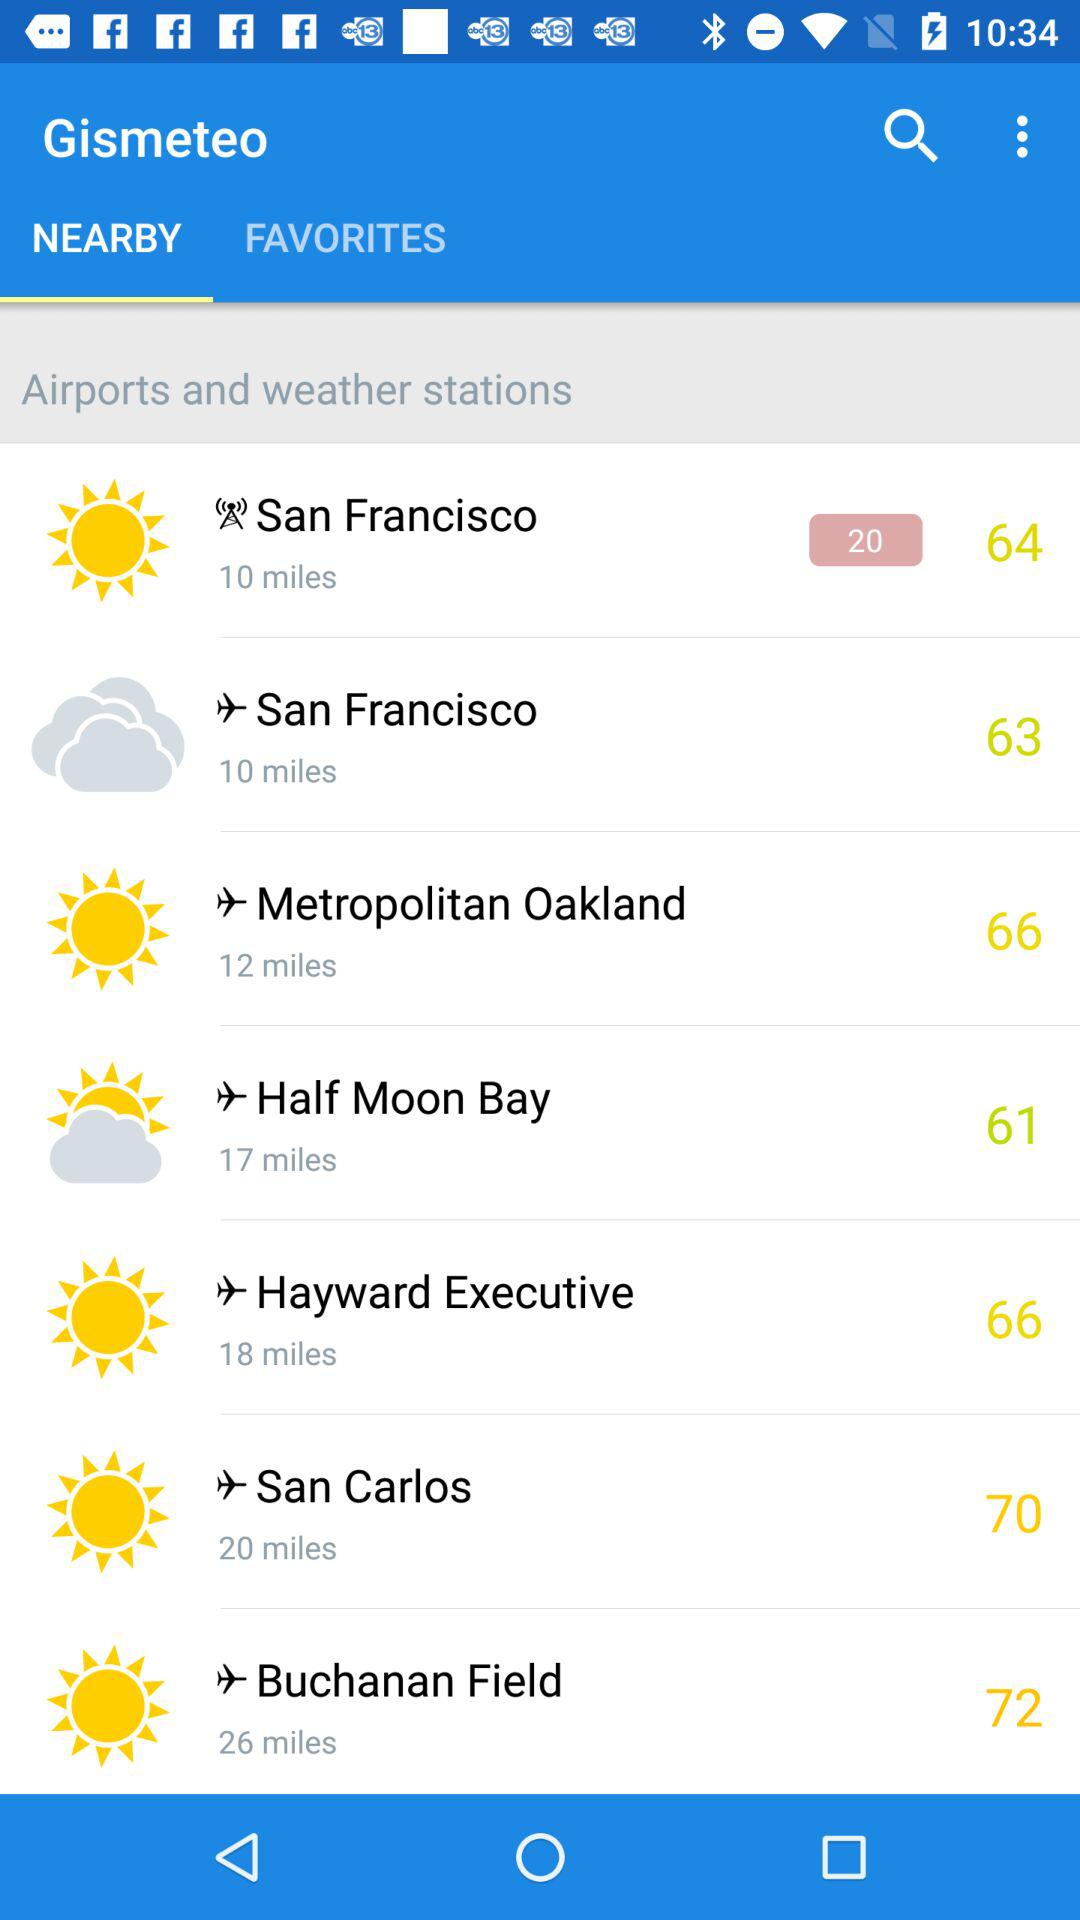Which tab has been selected? The tab that has been selected is "NEARBY". 